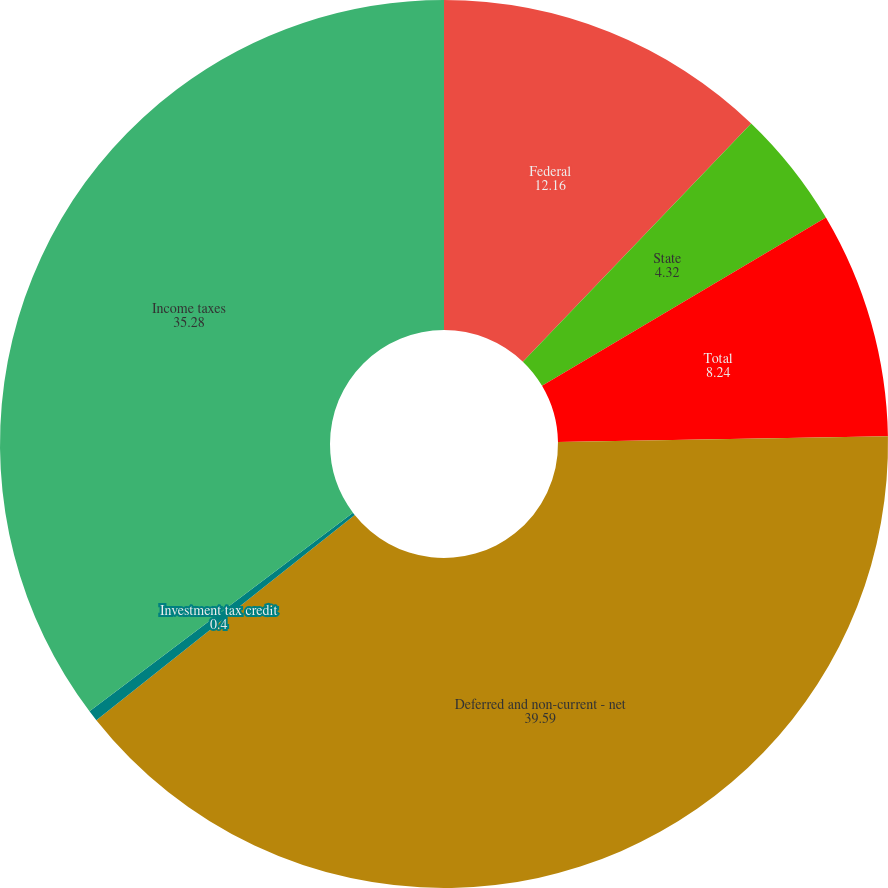Convert chart. <chart><loc_0><loc_0><loc_500><loc_500><pie_chart><fcel>Federal<fcel>State<fcel>Total<fcel>Deferred and non-current - net<fcel>Investment tax credit<fcel>Income taxes<nl><fcel>12.16%<fcel>4.32%<fcel>8.24%<fcel>39.59%<fcel>0.4%<fcel>35.28%<nl></chart> 